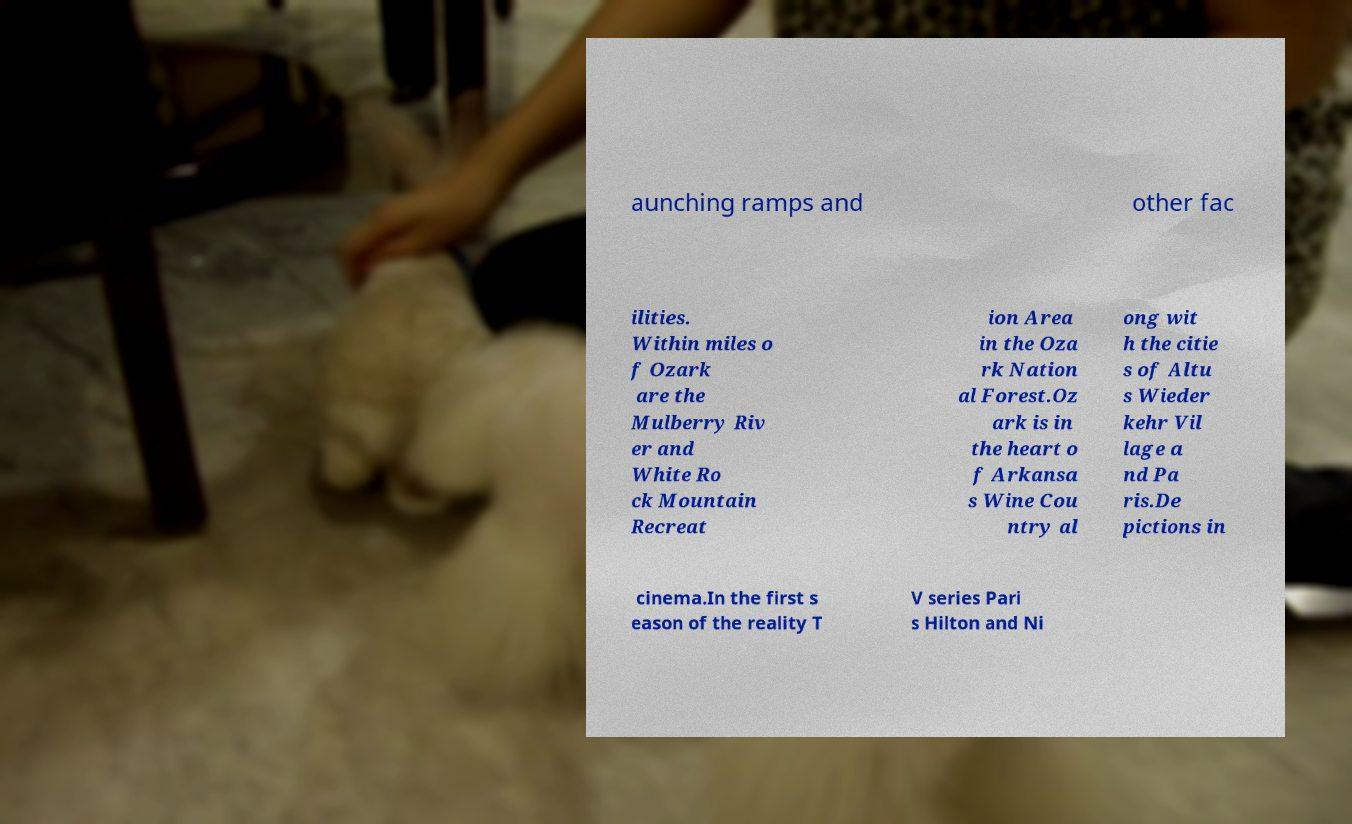Please read and relay the text visible in this image. What does it say? aunching ramps and other fac ilities. Within miles o f Ozark are the Mulberry Riv er and White Ro ck Mountain Recreat ion Area in the Oza rk Nation al Forest.Oz ark is in the heart o f Arkansa s Wine Cou ntry al ong wit h the citie s of Altu s Wieder kehr Vil lage a nd Pa ris.De pictions in cinema.In the first s eason of the reality T V series Pari s Hilton and Ni 